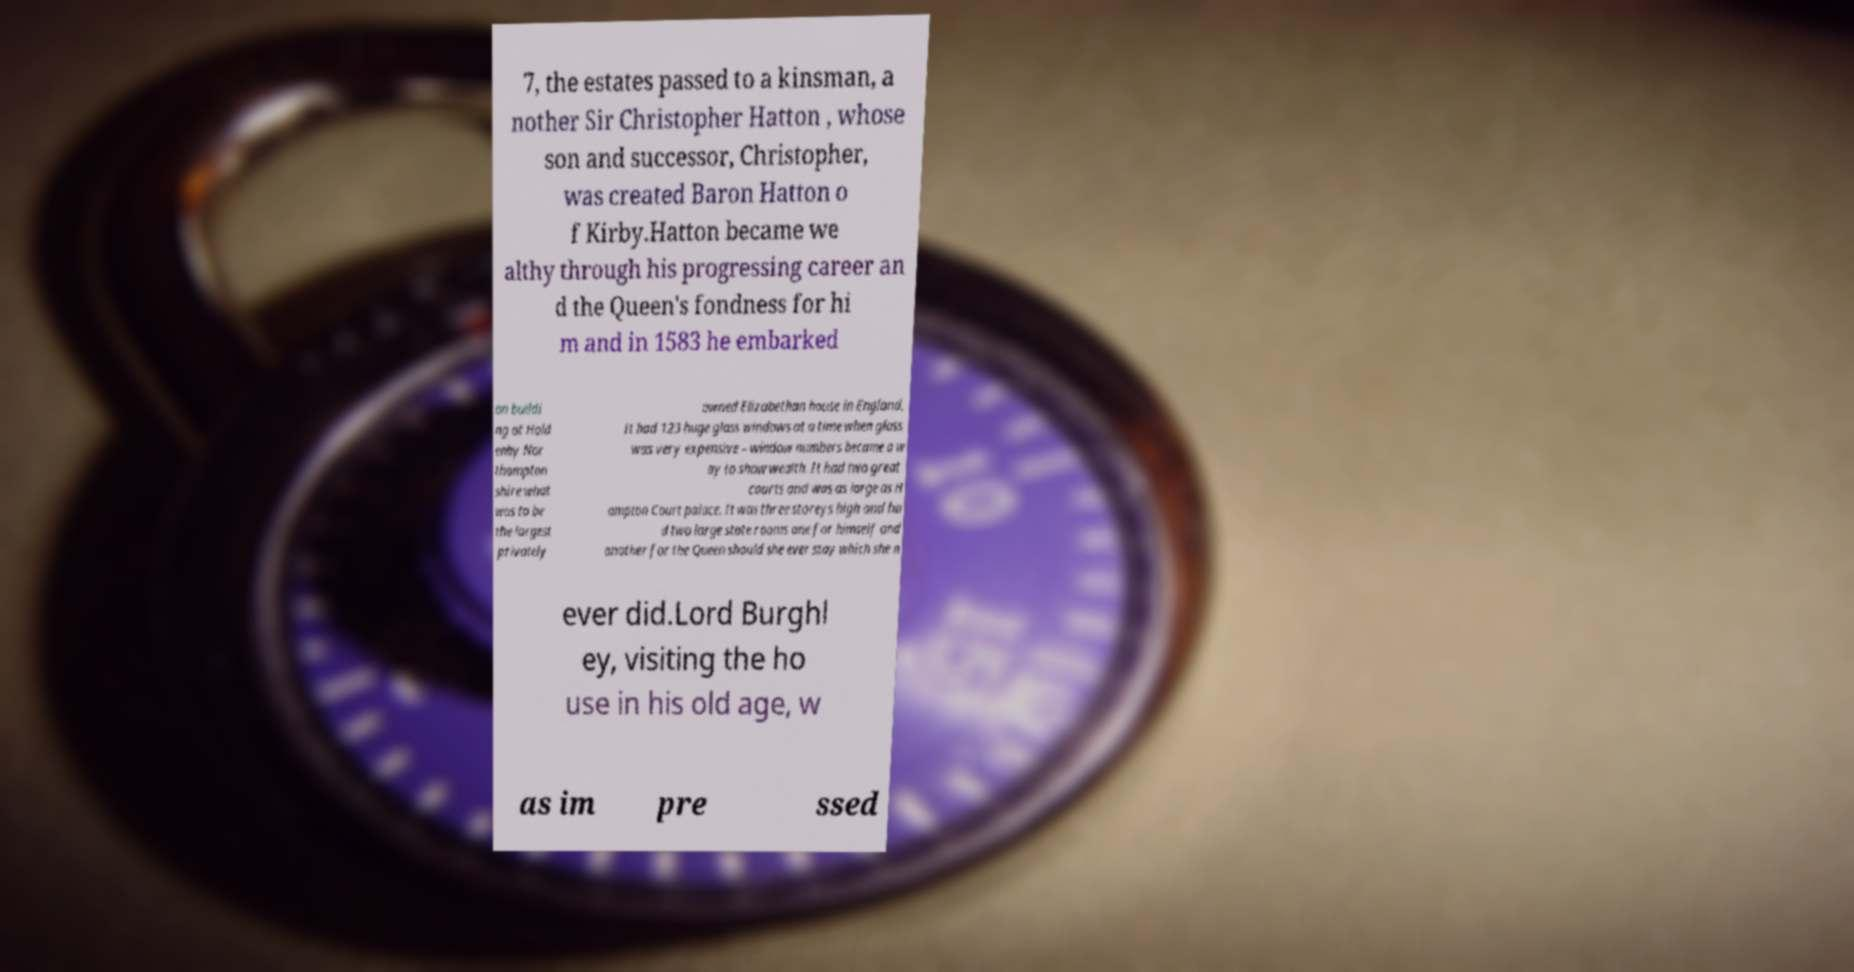There's text embedded in this image that I need extracted. Can you transcribe it verbatim? 7, the estates passed to a kinsman, a nother Sir Christopher Hatton , whose son and successor, Christopher, was created Baron Hatton o f Kirby.Hatton became we althy through his progressing career an d the Queen's fondness for hi m and in 1583 he embarked on buildi ng at Hold enby Nor thampton shire what was to be the largest privately owned Elizabethan house in England. It had 123 huge glass windows at a time when glass was very expensive – window numbers became a w ay to show wealth. It had two great courts and was as large as H ampton Court palace. It was three storeys high and ha d two large state rooms one for himself and another for the Queen should she ever stay which she n ever did.Lord Burghl ey, visiting the ho use in his old age, w as im pre ssed 